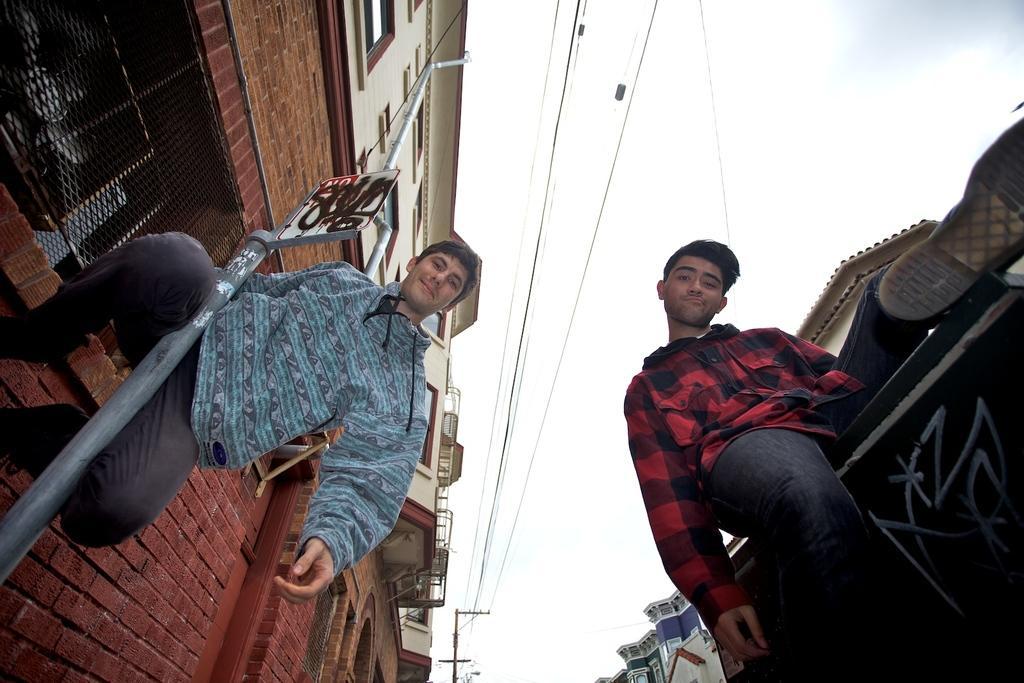In one or two sentences, can you explain what this image depicts? In this image we can see men of them one is climbing the pole and the other is climbing the wall. In the background we can see buildings, mesh, electric poles, electric cables and sky with clouds. 